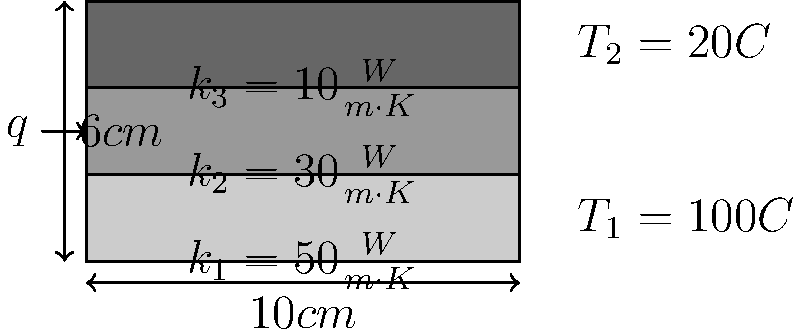As a database administrator familiar with data analysis, consider the heat transfer through a composite material shown in the diagram. The material consists of three layers with different thermal conductivities ($k_1$, $k_2$, and $k_3$) and a total thickness of 6 cm. Given the temperatures $T_1 = 100°C$ and $T_2 = 20°C$, calculate the heat flux $q$ through the composite material in $W/m^2$. To solve this problem, we'll use the concept of thermal resistance in series and Fourier's law of heat conduction. Let's break it down step by step:

1) The total thermal resistance is the sum of the resistances of each layer:

   $R_{total} = R_1 + R_2 + R_3$

2) The thermal resistance for each layer is given by:

   $R = \frac{L}{k \cdot A}$

   where $L$ is the thickness, $k$ is the thermal conductivity, and $A$ is the area.

3) Calculate the resistance for each layer:
   
   $R_1 = \frac{0.02}{50} = 0.0004 \frac{m^2 \cdot K}{W}$
   $R_2 = \frac{0.02}{30} = 0.000667 \frac{m^2 \cdot K}{W}$
   $R_3 = \frac{0.02}{10} = 0.002 \frac{m^2 \cdot K}{W}$

4) Sum up the resistances:

   $R_{total} = 0.0004 + 0.000667 + 0.002 = 0.003067 \frac{m^2 \cdot K}{W}$

5) Use Fourier's law to calculate the heat flux:

   $q = \frac{\Delta T}{R_{total}} = \frac{T_1 - T_2}{R_{total}}$

6) Plug in the values:

   $q = \frac{100 - 20}{0.003067} = 26084.77 W/m^2$

Therefore, the heat flux through the composite material is approximately 26,085 W/m².
Answer: 26,085 W/m² 